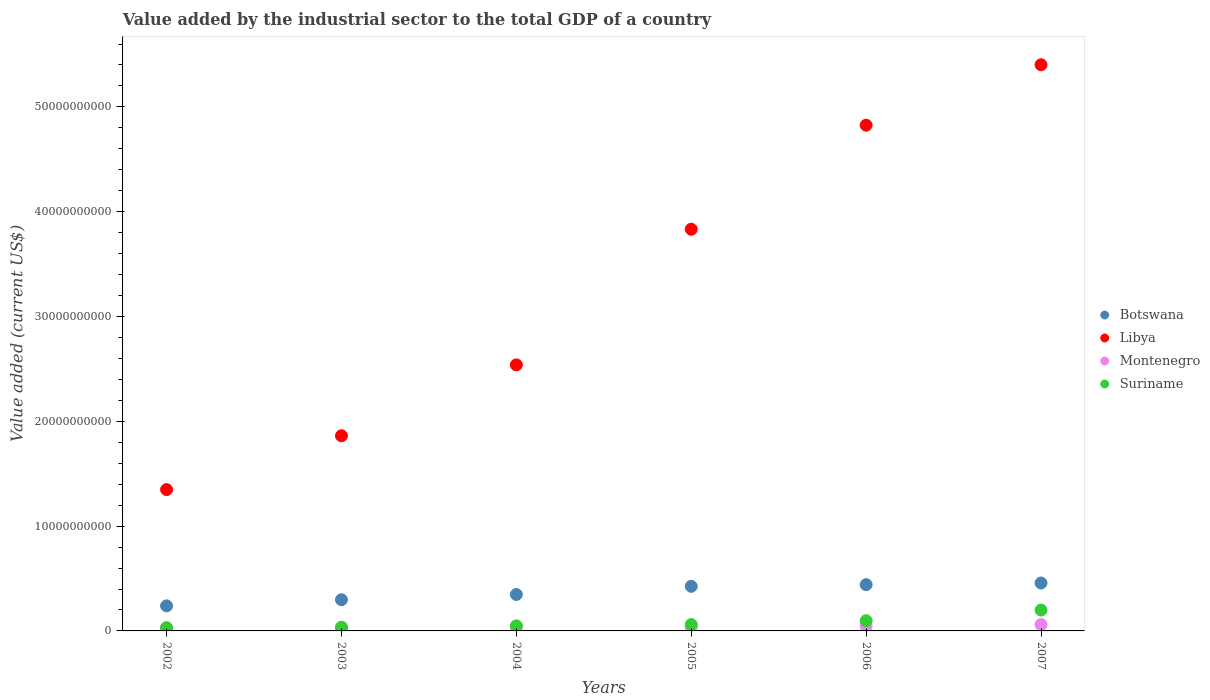Is the number of dotlines equal to the number of legend labels?
Give a very brief answer. Yes. What is the value added by the industrial sector to the total GDP in Montenegro in 2005?
Offer a terse response. 3.91e+08. Across all years, what is the maximum value added by the industrial sector to the total GDP in Montenegro?
Your answer should be very brief. 6.09e+08. Across all years, what is the minimum value added by the industrial sector to the total GDP in Botswana?
Offer a very short reply. 2.39e+09. In which year was the value added by the industrial sector to the total GDP in Libya minimum?
Provide a succinct answer. 2002. What is the total value added by the industrial sector to the total GDP in Libya in the graph?
Offer a terse response. 1.98e+11. What is the difference between the value added by the industrial sector to the total GDP in Libya in 2003 and that in 2005?
Give a very brief answer. -1.97e+1. What is the difference between the value added by the industrial sector to the total GDP in Libya in 2006 and the value added by the industrial sector to the total GDP in Montenegro in 2007?
Provide a short and direct response. 4.76e+1. What is the average value added by the industrial sector to the total GDP in Suriname per year?
Ensure brevity in your answer.  7.86e+08. In the year 2007, what is the difference between the value added by the industrial sector to the total GDP in Montenegro and value added by the industrial sector to the total GDP in Botswana?
Your response must be concise. -3.96e+09. In how many years, is the value added by the industrial sector to the total GDP in Botswana greater than 20000000000 US$?
Give a very brief answer. 0. What is the ratio of the value added by the industrial sector to the total GDP in Montenegro in 2002 to that in 2007?
Provide a short and direct response. 0.46. Is the value added by the industrial sector to the total GDP in Libya in 2005 less than that in 2006?
Your response must be concise. Yes. Is the difference between the value added by the industrial sector to the total GDP in Montenegro in 2003 and 2007 greater than the difference between the value added by the industrial sector to the total GDP in Botswana in 2003 and 2007?
Your answer should be compact. Yes. What is the difference between the highest and the second highest value added by the industrial sector to the total GDP in Montenegro?
Your answer should be compact. 1.60e+08. What is the difference between the highest and the lowest value added by the industrial sector to the total GDP in Libya?
Provide a succinct answer. 4.05e+1. Is it the case that in every year, the sum of the value added by the industrial sector to the total GDP in Botswana and value added by the industrial sector to the total GDP in Montenegro  is greater than the sum of value added by the industrial sector to the total GDP in Suriname and value added by the industrial sector to the total GDP in Libya?
Make the answer very short. No. Does the value added by the industrial sector to the total GDP in Montenegro monotonically increase over the years?
Your response must be concise. No. Is the value added by the industrial sector to the total GDP in Botswana strictly greater than the value added by the industrial sector to the total GDP in Montenegro over the years?
Your response must be concise. Yes. How many years are there in the graph?
Ensure brevity in your answer.  6. What is the difference between two consecutive major ticks on the Y-axis?
Make the answer very short. 1.00e+1. Does the graph contain any zero values?
Make the answer very short. No. Does the graph contain grids?
Offer a very short reply. No. Where does the legend appear in the graph?
Ensure brevity in your answer.  Center right. How many legend labels are there?
Ensure brevity in your answer.  4. What is the title of the graph?
Ensure brevity in your answer.  Value added by the industrial sector to the total GDP of a country. What is the label or title of the Y-axis?
Make the answer very short. Value added (current US$). What is the Value added (current US$) of Botswana in 2002?
Your answer should be very brief. 2.39e+09. What is the Value added (current US$) in Libya in 2002?
Give a very brief answer. 1.35e+1. What is the Value added (current US$) in Montenegro in 2002?
Your answer should be very brief. 2.77e+08. What is the Value added (current US$) in Suriname in 2002?
Your answer should be very brief. 3.08e+08. What is the Value added (current US$) in Botswana in 2003?
Make the answer very short. 2.98e+09. What is the Value added (current US$) of Libya in 2003?
Your answer should be compact. 1.86e+1. What is the Value added (current US$) of Montenegro in 2003?
Provide a succinct answer. 3.30e+08. What is the Value added (current US$) of Suriname in 2003?
Your answer should be compact. 3.55e+08. What is the Value added (current US$) of Botswana in 2004?
Provide a succinct answer. 3.48e+09. What is the Value added (current US$) of Libya in 2004?
Your answer should be compact. 2.54e+1. What is the Value added (current US$) in Montenegro in 2004?
Provide a short and direct response. 3.93e+08. What is the Value added (current US$) in Suriname in 2004?
Keep it short and to the point. 4.82e+08. What is the Value added (current US$) of Botswana in 2005?
Your answer should be very brief. 4.26e+09. What is the Value added (current US$) in Libya in 2005?
Give a very brief answer. 3.83e+1. What is the Value added (current US$) in Montenegro in 2005?
Make the answer very short. 3.91e+08. What is the Value added (current US$) of Suriname in 2005?
Keep it short and to the point. 6.07e+08. What is the Value added (current US$) in Botswana in 2006?
Offer a very short reply. 4.41e+09. What is the Value added (current US$) in Libya in 2006?
Provide a succinct answer. 4.83e+1. What is the Value added (current US$) of Montenegro in 2006?
Give a very brief answer. 4.49e+08. What is the Value added (current US$) in Suriname in 2006?
Your answer should be very brief. 9.76e+08. What is the Value added (current US$) in Botswana in 2007?
Keep it short and to the point. 4.57e+09. What is the Value added (current US$) of Libya in 2007?
Your answer should be compact. 5.40e+1. What is the Value added (current US$) in Montenegro in 2007?
Your answer should be very brief. 6.09e+08. What is the Value added (current US$) in Suriname in 2007?
Offer a very short reply. 1.99e+09. Across all years, what is the maximum Value added (current US$) in Botswana?
Your answer should be very brief. 4.57e+09. Across all years, what is the maximum Value added (current US$) of Libya?
Keep it short and to the point. 5.40e+1. Across all years, what is the maximum Value added (current US$) of Montenegro?
Keep it short and to the point. 6.09e+08. Across all years, what is the maximum Value added (current US$) in Suriname?
Ensure brevity in your answer.  1.99e+09. Across all years, what is the minimum Value added (current US$) of Botswana?
Provide a short and direct response. 2.39e+09. Across all years, what is the minimum Value added (current US$) in Libya?
Ensure brevity in your answer.  1.35e+1. Across all years, what is the minimum Value added (current US$) of Montenegro?
Your answer should be very brief. 2.77e+08. Across all years, what is the minimum Value added (current US$) of Suriname?
Your answer should be compact. 3.08e+08. What is the total Value added (current US$) in Botswana in the graph?
Ensure brevity in your answer.  2.21e+1. What is the total Value added (current US$) of Libya in the graph?
Make the answer very short. 1.98e+11. What is the total Value added (current US$) of Montenegro in the graph?
Offer a very short reply. 2.45e+09. What is the total Value added (current US$) in Suriname in the graph?
Keep it short and to the point. 4.72e+09. What is the difference between the Value added (current US$) of Botswana in 2002 and that in 2003?
Keep it short and to the point. -5.85e+08. What is the difference between the Value added (current US$) of Libya in 2002 and that in 2003?
Give a very brief answer. -5.14e+09. What is the difference between the Value added (current US$) in Montenegro in 2002 and that in 2003?
Offer a terse response. -5.26e+07. What is the difference between the Value added (current US$) in Suriname in 2002 and that in 2003?
Give a very brief answer. -4.67e+07. What is the difference between the Value added (current US$) of Botswana in 2002 and that in 2004?
Provide a short and direct response. -1.09e+09. What is the difference between the Value added (current US$) of Libya in 2002 and that in 2004?
Provide a short and direct response. -1.19e+1. What is the difference between the Value added (current US$) in Montenegro in 2002 and that in 2004?
Provide a short and direct response. -1.16e+08. What is the difference between the Value added (current US$) of Suriname in 2002 and that in 2004?
Your answer should be very brief. -1.74e+08. What is the difference between the Value added (current US$) in Botswana in 2002 and that in 2005?
Your answer should be compact. -1.86e+09. What is the difference between the Value added (current US$) of Libya in 2002 and that in 2005?
Your response must be concise. -2.48e+1. What is the difference between the Value added (current US$) of Montenegro in 2002 and that in 2005?
Make the answer very short. -1.14e+08. What is the difference between the Value added (current US$) of Suriname in 2002 and that in 2005?
Make the answer very short. -2.99e+08. What is the difference between the Value added (current US$) in Botswana in 2002 and that in 2006?
Provide a short and direct response. -2.02e+09. What is the difference between the Value added (current US$) of Libya in 2002 and that in 2006?
Ensure brevity in your answer.  -3.48e+1. What is the difference between the Value added (current US$) of Montenegro in 2002 and that in 2006?
Keep it short and to the point. -1.71e+08. What is the difference between the Value added (current US$) in Suriname in 2002 and that in 2006?
Your answer should be compact. -6.68e+08. What is the difference between the Value added (current US$) in Botswana in 2002 and that in 2007?
Your response must be concise. -2.18e+09. What is the difference between the Value added (current US$) in Libya in 2002 and that in 2007?
Provide a succinct answer. -4.05e+1. What is the difference between the Value added (current US$) of Montenegro in 2002 and that in 2007?
Provide a short and direct response. -3.31e+08. What is the difference between the Value added (current US$) of Suriname in 2002 and that in 2007?
Your response must be concise. -1.68e+09. What is the difference between the Value added (current US$) in Botswana in 2003 and that in 2004?
Give a very brief answer. -5.02e+08. What is the difference between the Value added (current US$) in Libya in 2003 and that in 2004?
Your answer should be very brief. -6.77e+09. What is the difference between the Value added (current US$) of Montenegro in 2003 and that in 2004?
Your answer should be very brief. -6.33e+07. What is the difference between the Value added (current US$) in Suriname in 2003 and that in 2004?
Keep it short and to the point. -1.27e+08. What is the difference between the Value added (current US$) of Botswana in 2003 and that in 2005?
Give a very brief answer. -1.28e+09. What is the difference between the Value added (current US$) of Libya in 2003 and that in 2005?
Your answer should be compact. -1.97e+1. What is the difference between the Value added (current US$) in Montenegro in 2003 and that in 2005?
Your answer should be very brief. -6.13e+07. What is the difference between the Value added (current US$) in Suriname in 2003 and that in 2005?
Offer a very short reply. -2.52e+08. What is the difference between the Value added (current US$) of Botswana in 2003 and that in 2006?
Offer a terse response. -1.44e+09. What is the difference between the Value added (current US$) in Libya in 2003 and that in 2006?
Offer a terse response. -2.96e+1. What is the difference between the Value added (current US$) in Montenegro in 2003 and that in 2006?
Your answer should be compact. -1.19e+08. What is the difference between the Value added (current US$) in Suriname in 2003 and that in 2006?
Your response must be concise. -6.21e+08. What is the difference between the Value added (current US$) in Botswana in 2003 and that in 2007?
Your answer should be very brief. -1.60e+09. What is the difference between the Value added (current US$) in Libya in 2003 and that in 2007?
Keep it short and to the point. -3.54e+1. What is the difference between the Value added (current US$) of Montenegro in 2003 and that in 2007?
Your answer should be very brief. -2.79e+08. What is the difference between the Value added (current US$) of Suriname in 2003 and that in 2007?
Ensure brevity in your answer.  -1.64e+09. What is the difference between the Value added (current US$) in Botswana in 2004 and that in 2005?
Make the answer very short. -7.79e+08. What is the difference between the Value added (current US$) of Libya in 2004 and that in 2005?
Provide a succinct answer. -1.29e+1. What is the difference between the Value added (current US$) in Montenegro in 2004 and that in 2005?
Give a very brief answer. 1.93e+06. What is the difference between the Value added (current US$) of Suriname in 2004 and that in 2005?
Provide a succinct answer. -1.25e+08. What is the difference between the Value added (current US$) of Botswana in 2004 and that in 2006?
Make the answer very short. -9.37e+08. What is the difference between the Value added (current US$) in Libya in 2004 and that in 2006?
Your answer should be compact. -2.29e+1. What is the difference between the Value added (current US$) of Montenegro in 2004 and that in 2006?
Offer a terse response. -5.56e+07. What is the difference between the Value added (current US$) of Suriname in 2004 and that in 2006?
Your response must be concise. -4.94e+08. What is the difference between the Value added (current US$) in Botswana in 2004 and that in 2007?
Your response must be concise. -1.10e+09. What is the difference between the Value added (current US$) in Libya in 2004 and that in 2007?
Ensure brevity in your answer.  -2.86e+1. What is the difference between the Value added (current US$) in Montenegro in 2004 and that in 2007?
Provide a succinct answer. -2.16e+08. What is the difference between the Value added (current US$) of Suriname in 2004 and that in 2007?
Provide a short and direct response. -1.51e+09. What is the difference between the Value added (current US$) of Botswana in 2005 and that in 2006?
Provide a short and direct response. -1.58e+08. What is the difference between the Value added (current US$) in Libya in 2005 and that in 2006?
Give a very brief answer. -9.93e+09. What is the difference between the Value added (current US$) in Montenegro in 2005 and that in 2006?
Offer a very short reply. -5.75e+07. What is the difference between the Value added (current US$) of Suriname in 2005 and that in 2006?
Your answer should be compact. -3.69e+08. What is the difference between the Value added (current US$) in Botswana in 2005 and that in 2007?
Your response must be concise. -3.17e+08. What is the difference between the Value added (current US$) in Libya in 2005 and that in 2007?
Provide a short and direct response. -1.57e+1. What is the difference between the Value added (current US$) in Montenegro in 2005 and that in 2007?
Offer a terse response. -2.17e+08. What is the difference between the Value added (current US$) in Suriname in 2005 and that in 2007?
Your response must be concise. -1.38e+09. What is the difference between the Value added (current US$) in Botswana in 2006 and that in 2007?
Ensure brevity in your answer.  -1.58e+08. What is the difference between the Value added (current US$) in Libya in 2006 and that in 2007?
Your answer should be compact. -5.77e+09. What is the difference between the Value added (current US$) of Montenegro in 2006 and that in 2007?
Offer a terse response. -1.60e+08. What is the difference between the Value added (current US$) in Suriname in 2006 and that in 2007?
Provide a short and direct response. -1.01e+09. What is the difference between the Value added (current US$) of Botswana in 2002 and the Value added (current US$) of Libya in 2003?
Make the answer very short. -1.62e+1. What is the difference between the Value added (current US$) of Botswana in 2002 and the Value added (current US$) of Montenegro in 2003?
Keep it short and to the point. 2.06e+09. What is the difference between the Value added (current US$) in Botswana in 2002 and the Value added (current US$) in Suriname in 2003?
Ensure brevity in your answer.  2.04e+09. What is the difference between the Value added (current US$) of Libya in 2002 and the Value added (current US$) of Montenegro in 2003?
Give a very brief answer. 1.32e+1. What is the difference between the Value added (current US$) in Libya in 2002 and the Value added (current US$) in Suriname in 2003?
Provide a succinct answer. 1.31e+1. What is the difference between the Value added (current US$) of Montenegro in 2002 and the Value added (current US$) of Suriname in 2003?
Keep it short and to the point. -7.72e+07. What is the difference between the Value added (current US$) in Botswana in 2002 and the Value added (current US$) in Libya in 2004?
Offer a very short reply. -2.30e+1. What is the difference between the Value added (current US$) in Botswana in 2002 and the Value added (current US$) in Montenegro in 2004?
Ensure brevity in your answer.  2.00e+09. What is the difference between the Value added (current US$) of Botswana in 2002 and the Value added (current US$) of Suriname in 2004?
Give a very brief answer. 1.91e+09. What is the difference between the Value added (current US$) in Libya in 2002 and the Value added (current US$) in Montenegro in 2004?
Offer a terse response. 1.31e+1. What is the difference between the Value added (current US$) of Libya in 2002 and the Value added (current US$) of Suriname in 2004?
Your answer should be compact. 1.30e+1. What is the difference between the Value added (current US$) of Montenegro in 2002 and the Value added (current US$) of Suriname in 2004?
Your response must be concise. -2.04e+08. What is the difference between the Value added (current US$) in Botswana in 2002 and the Value added (current US$) in Libya in 2005?
Offer a terse response. -3.59e+1. What is the difference between the Value added (current US$) in Botswana in 2002 and the Value added (current US$) in Montenegro in 2005?
Your response must be concise. 2.00e+09. What is the difference between the Value added (current US$) of Botswana in 2002 and the Value added (current US$) of Suriname in 2005?
Keep it short and to the point. 1.78e+09. What is the difference between the Value added (current US$) in Libya in 2002 and the Value added (current US$) in Montenegro in 2005?
Offer a terse response. 1.31e+1. What is the difference between the Value added (current US$) in Libya in 2002 and the Value added (current US$) in Suriname in 2005?
Your response must be concise. 1.29e+1. What is the difference between the Value added (current US$) of Montenegro in 2002 and the Value added (current US$) of Suriname in 2005?
Offer a terse response. -3.30e+08. What is the difference between the Value added (current US$) of Botswana in 2002 and the Value added (current US$) of Libya in 2006?
Provide a short and direct response. -4.59e+1. What is the difference between the Value added (current US$) in Botswana in 2002 and the Value added (current US$) in Montenegro in 2006?
Your answer should be very brief. 1.94e+09. What is the difference between the Value added (current US$) of Botswana in 2002 and the Value added (current US$) of Suriname in 2006?
Provide a short and direct response. 1.42e+09. What is the difference between the Value added (current US$) of Libya in 2002 and the Value added (current US$) of Montenegro in 2006?
Your response must be concise. 1.30e+1. What is the difference between the Value added (current US$) of Libya in 2002 and the Value added (current US$) of Suriname in 2006?
Make the answer very short. 1.25e+1. What is the difference between the Value added (current US$) in Montenegro in 2002 and the Value added (current US$) in Suriname in 2006?
Make the answer very short. -6.98e+08. What is the difference between the Value added (current US$) in Botswana in 2002 and the Value added (current US$) in Libya in 2007?
Your answer should be very brief. -5.16e+1. What is the difference between the Value added (current US$) in Botswana in 2002 and the Value added (current US$) in Montenegro in 2007?
Give a very brief answer. 1.78e+09. What is the difference between the Value added (current US$) of Botswana in 2002 and the Value added (current US$) of Suriname in 2007?
Make the answer very short. 4.01e+08. What is the difference between the Value added (current US$) of Libya in 2002 and the Value added (current US$) of Montenegro in 2007?
Provide a short and direct response. 1.29e+1. What is the difference between the Value added (current US$) of Libya in 2002 and the Value added (current US$) of Suriname in 2007?
Keep it short and to the point. 1.15e+1. What is the difference between the Value added (current US$) in Montenegro in 2002 and the Value added (current US$) in Suriname in 2007?
Make the answer very short. -1.71e+09. What is the difference between the Value added (current US$) in Botswana in 2003 and the Value added (current US$) in Libya in 2004?
Provide a succinct answer. -2.24e+1. What is the difference between the Value added (current US$) of Botswana in 2003 and the Value added (current US$) of Montenegro in 2004?
Ensure brevity in your answer.  2.58e+09. What is the difference between the Value added (current US$) of Botswana in 2003 and the Value added (current US$) of Suriname in 2004?
Your answer should be very brief. 2.49e+09. What is the difference between the Value added (current US$) of Libya in 2003 and the Value added (current US$) of Montenegro in 2004?
Give a very brief answer. 1.82e+1. What is the difference between the Value added (current US$) in Libya in 2003 and the Value added (current US$) in Suriname in 2004?
Your response must be concise. 1.81e+1. What is the difference between the Value added (current US$) of Montenegro in 2003 and the Value added (current US$) of Suriname in 2004?
Offer a terse response. -1.52e+08. What is the difference between the Value added (current US$) in Botswana in 2003 and the Value added (current US$) in Libya in 2005?
Make the answer very short. -3.54e+1. What is the difference between the Value added (current US$) of Botswana in 2003 and the Value added (current US$) of Montenegro in 2005?
Offer a very short reply. 2.58e+09. What is the difference between the Value added (current US$) in Botswana in 2003 and the Value added (current US$) in Suriname in 2005?
Your response must be concise. 2.37e+09. What is the difference between the Value added (current US$) in Libya in 2003 and the Value added (current US$) in Montenegro in 2005?
Offer a terse response. 1.82e+1. What is the difference between the Value added (current US$) of Libya in 2003 and the Value added (current US$) of Suriname in 2005?
Your answer should be compact. 1.80e+1. What is the difference between the Value added (current US$) of Montenegro in 2003 and the Value added (current US$) of Suriname in 2005?
Provide a short and direct response. -2.77e+08. What is the difference between the Value added (current US$) in Botswana in 2003 and the Value added (current US$) in Libya in 2006?
Provide a short and direct response. -4.53e+1. What is the difference between the Value added (current US$) of Botswana in 2003 and the Value added (current US$) of Montenegro in 2006?
Keep it short and to the point. 2.53e+09. What is the difference between the Value added (current US$) of Botswana in 2003 and the Value added (current US$) of Suriname in 2006?
Provide a succinct answer. 2.00e+09. What is the difference between the Value added (current US$) in Libya in 2003 and the Value added (current US$) in Montenegro in 2006?
Your answer should be very brief. 1.82e+1. What is the difference between the Value added (current US$) in Libya in 2003 and the Value added (current US$) in Suriname in 2006?
Make the answer very short. 1.76e+1. What is the difference between the Value added (current US$) of Montenegro in 2003 and the Value added (current US$) of Suriname in 2006?
Your response must be concise. -6.46e+08. What is the difference between the Value added (current US$) of Botswana in 2003 and the Value added (current US$) of Libya in 2007?
Offer a terse response. -5.10e+1. What is the difference between the Value added (current US$) of Botswana in 2003 and the Value added (current US$) of Montenegro in 2007?
Your response must be concise. 2.37e+09. What is the difference between the Value added (current US$) of Botswana in 2003 and the Value added (current US$) of Suriname in 2007?
Your answer should be compact. 9.85e+08. What is the difference between the Value added (current US$) in Libya in 2003 and the Value added (current US$) in Montenegro in 2007?
Your response must be concise. 1.80e+1. What is the difference between the Value added (current US$) of Libya in 2003 and the Value added (current US$) of Suriname in 2007?
Offer a terse response. 1.66e+1. What is the difference between the Value added (current US$) of Montenegro in 2003 and the Value added (current US$) of Suriname in 2007?
Keep it short and to the point. -1.66e+09. What is the difference between the Value added (current US$) in Botswana in 2004 and the Value added (current US$) in Libya in 2005?
Provide a succinct answer. -3.49e+1. What is the difference between the Value added (current US$) of Botswana in 2004 and the Value added (current US$) of Montenegro in 2005?
Offer a very short reply. 3.09e+09. What is the difference between the Value added (current US$) in Botswana in 2004 and the Value added (current US$) in Suriname in 2005?
Provide a short and direct response. 2.87e+09. What is the difference between the Value added (current US$) of Libya in 2004 and the Value added (current US$) of Montenegro in 2005?
Ensure brevity in your answer.  2.50e+1. What is the difference between the Value added (current US$) in Libya in 2004 and the Value added (current US$) in Suriname in 2005?
Provide a succinct answer. 2.48e+1. What is the difference between the Value added (current US$) in Montenegro in 2004 and the Value added (current US$) in Suriname in 2005?
Your response must be concise. -2.14e+08. What is the difference between the Value added (current US$) in Botswana in 2004 and the Value added (current US$) in Libya in 2006?
Keep it short and to the point. -4.48e+1. What is the difference between the Value added (current US$) in Botswana in 2004 and the Value added (current US$) in Montenegro in 2006?
Your answer should be very brief. 3.03e+09. What is the difference between the Value added (current US$) of Botswana in 2004 and the Value added (current US$) of Suriname in 2006?
Make the answer very short. 2.50e+09. What is the difference between the Value added (current US$) in Libya in 2004 and the Value added (current US$) in Montenegro in 2006?
Your response must be concise. 2.49e+1. What is the difference between the Value added (current US$) in Libya in 2004 and the Value added (current US$) in Suriname in 2006?
Give a very brief answer. 2.44e+1. What is the difference between the Value added (current US$) in Montenegro in 2004 and the Value added (current US$) in Suriname in 2006?
Offer a terse response. -5.82e+08. What is the difference between the Value added (current US$) of Botswana in 2004 and the Value added (current US$) of Libya in 2007?
Make the answer very short. -5.05e+1. What is the difference between the Value added (current US$) in Botswana in 2004 and the Value added (current US$) in Montenegro in 2007?
Provide a short and direct response. 2.87e+09. What is the difference between the Value added (current US$) of Botswana in 2004 and the Value added (current US$) of Suriname in 2007?
Give a very brief answer. 1.49e+09. What is the difference between the Value added (current US$) in Libya in 2004 and the Value added (current US$) in Montenegro in 2007?
Provide a short and direct response. 2.48e+1. What is the difference between the Value added (current US$) in Libya in 2004 and the Value added (current US$) in Suriname in 2007?
Provide a short and direct response. 2.34e+1. What is the difference between the Value added (current US$) in Montenegro in 2004 and the Value added (current US$) in Suriname in 2007?
Provide a succinct answer. -1.60e+09. What is the difference between the Value added (current US$) of Botswana in 2005 and the Value added (current US$) of Libya in 2006?
Offer a terse response. -4.40e+1. What is the difference between the Value added (current US$) in Botswana in 2005 and the Value added (current US$) in Montenegro in 2006?
Provide a succinct answer. 3.81e+09. What is the difference between the Value added (current US$) of Botswana in 2005 and the Value added (current US$) of Suriname in 2006?
Offer a terse response. 3.28e+09. What is the difference between the Value added (current US$) of Libya in 2005 and the Value added (current US$) of Montenegro in 2006?
Your answer should be very brief. 3.79e+1. What is the difference between the Value added (current US$) of Libya in 2005 and the Value added (current US$) of Suriname in 2006?
Offer a terse response. 3.74e+1. What is the difference between the Value added (current US$) of Montenegro in 2005 and the Value added (current US$) of Suriname in 2006?
Your response must be concise. -5.84e+08. What is the difference between the Value added (current US$) in Botswana in 2005 and the Value added (current US$) in Libya in 2007?
Offer a terse response. -4.98e+1. What is the difference between the Value added (current US$) of Botswana in 2005 and the Value added (current US$) of Montenegro in 2007?
Give a very brief answer. 3.65e+09. What is the difference between the Value added (current US$) in Botswana in 2005 and the Value added (current US$) in Suriname in 2007?
Your answer should be compact. 2.27e+09. What is the difference between the Value added (current US$) in Libya in 2005 and the Value added (current US$) in Montenegro in 2007?
Your answer should be compact. 3.77e+1. What is the difference between the Value added (current US$) of Libya in 2005 and the Value added (current US$) of Suriname in 2007?
Provide a short and direct response. 3.63e+1. What is the difference between the Value added (current US$) in Montenegro in 2005 and the Value added (current US$) in Suriname in 2007?
Give a very brief answer. -1.60e+09. What is the difference between the Value added (current US$) in Botswana in 2006 and the Value added (current US$) in Libya in 2007?
Offer a terse response. -4.96e+1. What is the difference between the Value added (current US$) in Botswana in 2006 and the Value added (current US$) in Montenegro in 2007?
Make the answer very short. 3.81e+09. What is the difference between the Value added (current US$) of Botswana in 2006 and the Value added (current US$) of Suriname in 2007?
Offer a terse response. 2.42e+09. What is the difference between the Value added (current US$) in Libya in 2006 and the Value added (current US$) in Montenegro in 2007?
Offer a terse response. 4.76e+1. What is the difference between the Value added (current US$) in Libya in 2006 and the Value added (current US$) in Suriname in 2007?
Offer a terse response. 4.63e+1. What is the difference between the Value added (current US$) of Montenegro in 2006 and the Value added (current US$) of Suriname in 2007?
Provide a short and direct response. -1.54e+09. What is the average Value added (current US$) of Botswana per year?
Your answer should be very brief. 3.68e+09. What is the average Value added (current US$) in Libya per year?
Your answer should be very brief. 3.30e+1. What is the average Value added (current US$) of Montenegro per year?
Offer a terse response. 4.08e+08. What is the average Value added (current US$) of Suriname per year?
Offer a terse response. 7.86e+08. In the year 2002, what is the difference between the Value added (current US$) of Botswana and Value added (current US$) of Libya?
Your answer should be very brief. -1.11e+1. In the year 2002, what is the difference between the Value added (current US$) of Botswana and Value added (current US$) of Montenegro?
Offer a terse response. 2.11e+09. In the year 2002, what is the difference between the Value added (current US$) in Botswana and Value added (current US$) in Suriname?
Provide a succinct answer. 2.08e+09. In the year 2002, what is the difference between the Value added (current US$) of Libya and Value added (current US$) of Montenegro?
Provide a short and direct response. 1.32e+1. In the year 2002, what is the difference between the Value added (current US$) of Libya and Value added (current US$) of Suriname?
Your answer should be compact. 1.32e+1. In the year 2002, what is the difference between the Value added (current US$) of Montenegro and Value added (current US$) of Suriname?
Offer a very short reply. -3.06e+07. In the year 2003, what is the difference between the Value added (current US$) in Botswana and Value added (current US$) in Libya?
Your answer should be very brief. -1.56e+1. In the year 2003, what is the difference between the Value added (current US$) in Botswana and Value added (current US$) in Montenegro?
Keep it short and to the point. 2.65e+09. In the year 2003, what is the difference between the Value added (current US$) in Botswana and Value added (current US$) in Suriname?
Provide a short and direct response. 2.62e+09. In the year 2003, what is the difference between the Value added (current US$) of Libya and Value added (current US$) of Montenegro?
Your response must be concise. 1.83e+1. In the year 2003, what is the difference between the Value added (current US$) of Libya and Value added (current US$) of Suriname?
Your response must be concise. 1.83e+1. In the year 2003, what is the difference between the Value added (current US$) of Montenegro and Value added (current US$) of Suriname?
Offer a very short reply. -2.46e+07. In the year 2004, what is the difference between the Value added (current US$) of Botswana and Value added (current US$) of Libya?
Make the answer very short. -2.19e+1. In the year 2004, what is the difference between the Value added (current US$) in Botswana and Value added (current US$) in Montenegro?
Provide a short and direct response. 3.08e+09. In the year 2004, what is the difference between the Value added (current US$) in Botswana and Value added (current US$) in Suriname?
Ensure brevity in your answer.  3.00e+09. In the year 2004, what is the difference between the Value added (current US$) in Libya and Value added (current US$) in Montenegro?
Offer a very short reply. 2.50e+1. In the year 2004, what is the difference between the Value added (current US$) of Libya and Value added (current US$) of Suriname?
Keep it short and to the point. 2.49e+1. In the year 2004, what is the difference between the Value added (current US$) in Montenegro and Value added (current US$) in Suriname?
Ensure brevity in your answer.  -8.85e+07. In the year 2005, what is the difference between the Value added (current US$) in Botswana and Value added (current US$) in Libya?
Your answer should be very brief. -3.41e+1. In the year 2005, what is the difference between the Value added (current US$) in Botswana and Value added (current US$) in Montenegro?
Keep it short and to the point. 3.86e+09. In the year 2005, what is the difference between the Value added (current US$) in Botswana and Value added (current US$) in Suriname?
Provide a short and direct response. 3.65e+09. In the year 2005, what is the difference between the Value added (current US$) in Libya and Value added (current US$) in Montenegro?
Provide a short and direct response. 3.79e+1. In the year 2005, what is the difference between the Value added (current US$) of Libya and Value added (current US$) of Suriname?
Your answer should be compact. 3.77e+1. In the year 2005, what is the difference between the Value added (current US$) in Montenegro and Value added (current US$) in Suriname?
Your response must be concise. -2.16e+08. In the year 2006, what is the difference between the Value added (current US$) of Botswana and Value added (current US$) of Libya?
Your response must be concise. -4.38e+1. In the year 2006, what is the difference between the Value added (current US$) in Botswana and Value added (current US$) in Montenegro?
Keep it short and to the point. 3.97e+09. In the year 2006, what is the difference between the Value added (current US$) in Botswana and Value added (current US$) in Suriname?
Provide a succinct answer. 3.44e+09. In the year 2006, what is the difference between the Value added (current US$) in Libya and Value added (current US$) in Montenegro?
Ensure brevity in your answer.  4.78e+1. In the year 2006, what is the difference between the Value added (current US$) of Libya and Value added (current US$) of Suriname?
Ensure brevity in your answer.  4.73e+1. In the year 2006, what is the difference between the Value added (current US$) in Montenegro and Value added (current US$) in Suriname?
Give a very brief answer. -5.27e+08. In the year 2007, what is the difference between the Value added (current US$) in Botswana and Value added (current US$) in Libya?
Provide a succinct answer. -4.95e+1. In the year 2007, what is the difference between the Value added (current US$) in Botswana and Value added (current US$) in Montenegro?
Offer a very short reply. 3.96e+09. In the year 2007, what is the difference between the Value added (current US$) of Botswana and Value added (current US$) of Suriname?
Your response must be concise. 2.58e+09. In the year 2007, what is the difference between the Value added (current US$) of Libya and Value added (current US$) of Montenegro?
Provide a succinct answer. 5.34e+1. In the year 2007, what is the difference between the Value added (current US$) in Libya and Value added (current US$) in Suriname?
Your answer should be compact. 5.20e+1. In the year 2007, what is the difference between the Value added (current US$) of Montenegro and Value added (current US$) of Suriname?
Your response must be concise. -1.38e+09. What is the ratio of the Value added (current US$) in Botswana in 2002 to that in 2003?
Your answer should be very brief. 0.8. What is the ratio of the Value added (current US$) of Libya in 2002 to that in 2003?
Your answer should be compact. 0.72. What is the ratio of the Value added (current US$) of Montenegro in 2002 to that in 2003?
Offer a very short reply. 0.84. What is the ratio of the Value added (current US$) in Suriname in 2002 to that in 2003?
Keep it short and to the point. 0.87. What is the ratio of the Value added (current US$) of Botswana in 2002 to that in 2004?
Provide a short and direct response. 0.69. What is the ratio of the Value added (current US$) in Libya in 2002 to that in 2004?
Your response must be concise. 0.53. What is the ratio of the Value added (current US$) of Montenegro in 2002 to that in 2004?
Your response must be concise. 0.71. What is the ratio of the Value added (current US$) of Suriname in 2002 to that in 2004?
Your answer should be very brief. 0.64. What is the ratio of the Value added (current US$) in Botswana in 2002 to that in 2005?
Your answer should be very brief. 0.56. What is the ratio of the Value added (current US$) in Libya in 2002 to that in 2005?
Keep it short and to the point. 0.35. What is the ratio of the Value added (current US$) in Montenegro in 2002 to that in 2005?
Offer a very short reply. 0.71. What is the ratio of the Value added (current US$) in Suriname in 2002 to that in 2005?
Ensure brevity in your answer.  0.51. What is the ratio of the Value added (current US$) of Botswana in 2002 to that in 2006?
Offer a terse response. 0.54. What is the ratio of the Value added (current US$) of Libya in 2002 to that in 2006?
Provide a succinct answer. 0.28. What is the ratio of the Value added (current US$) in Montenegro in 2002 to that in 2006?
Keep it short and to the point. 0.62. What is the ratio of the Value added (current US$) in Suriname in 2002 to that in 2006?
Your answer should be compact. 0.32. What is the ratio of the Value added (current US$) in Botswana in 2002 to that in 2007?
Provide a short and direct response. 0.52. What is the ratio of the Value added (current US$) of Libya in 2002 to that in 2007?
Give a very brief answer. 0.25. What is the ratio of the Value added (current US$) in Montenegro in 2002 to that in 2007?
Offer a very short reply. 0.46. What is the ratio of the Value added (current US$) in Suriname in 2002 to that in 2007?
Keep it short and to the point. 0.15. What is the ratio of the Value added (current US$) of Botswana in 2003 to that in 2004?
Offer a very short reply. 0.86. What is the ratio of the Value added (current US$) in Libya in 2003 to that in 2004?
Provide a short and direct response. 0.73. What is the ratio of the Value added (current US$) of Montenegro in 2003 to that in 2004?
Offer a terse response. 0.84. What is the ratio of the Value added (current US$) in Suriname in 2003 to that in 2004?
Offer a terse response. 0.74. What is the ratio of the Value added (current US$) in Botswana in 2003 to that in 2005?
Give a very brief answer. 0.7. What is the ratio of the Value added (current US$) in Libya in 2003 to that in 2005?
Provide a succinct answer. 0.49. What is the ratio of the Value added (current US$) in Montenegro in 2003 to that in 2005?
Keep it short and to the point. 0.84. What is the ratio of the Value added (current US$) in Suriname in 2003 to that in 2005?
Offer a very short reply. 0.58. What is the ratio of the Value added (current US$) of Botswana in 2003 to that in 2006?
Make the answer very short. 0.67. What is the ratio of the Value added (current US$) of Libya in 2003 to that in 2006?
Keep it short and to the point. 0.39. What is the ratio of the Value added (current US$) in Montenegro in 2003 to that in 2006?
Provide a succinct answer. 0.74. What is the ratio of the Value added (current US$) of Suriname in 2003 to that in 2006?
Your answer should be compact. 0.36. What is the ratio of the Value added (current US$) of Botswana in 2003 to that in 2007?
Offer a terse response. 0.65. What is the ratio of the Value added (current US$) in Libya in 2003 to that in 2007?
Your answer should be compact. 0.34. What is the ratio of the Value added (current US$) of Montenegro in 2003 to that in 2007?
Give a very brief answer. 0.54. What is the ratio of the Value added (current US$) in Suriname in 2003 to that in 2007?
Keep it short and to the point. 0.18. What is the ratio of the Value added (current US$) of Botswana in 2004 to that in 2005?
Provide a short and direct response. 0.82. What is the ratio of the Value added (current US$) of Libya in 2004 to that in 2005?
Offer a very short reply. 0.66. What is the ratio of the Value added (current US$) in Suriname in 2004 to that in 2005?
Your answer should be very brief. 0.79. What is the ratio of the Value added (current US$) of Botswana in 2004 to that in 2006?
Ensure brevity in your answer.  0.79. What is the ratio of the Value added (current US$) of Libya in 2004 to that in 2006?
Your response must be concise. 0.53. What is the ratio of the Value added (current US$) in Montenegro in 2004 to that in 2006?
Offer a terse response. 0.88. What is the ratio of the Value added (current US$) of Suriname in 2004 to that in 2006?
Keep it short and to the point. 0.49. What is the ratio of the Value added (current US$) in Botswana in 2004 to that in 2007?
Offer a very short reply. 0.76. What is the ratio of the Value added (current US$) in Libya in 2004 to that in 2007?
Keep it short and to the point. 0.47. What is the ratio of the Value added (current US$) in Montenegro in 2004 to that in 2007?
Ensure brevity in your answer.  0.65. What is the ratio of the Value added (current US$) of Suriname in 2004 to that in 2007?
Keep it short and to the point. 0.24. What is the ratio of the Value added (current US$) of Botswana in 2005 to that in 2006?
Your answer should be compact. 0.96. What is the ratio of the Value added (current US$) in Libya in 2005 to that in 2006?
Provide a succinct answer. 0.79. What is the ratio of the Value added (current US$) of Montenegro in 2005 to that in 2006?
Offer a terse response. 0.87. What is the ratio of the Value added (current US$) in Suriname in 2005 to that in 2006?
Your answer should be compact. 0.62. What is the ratio of the Value added (current US$) in Botswana in 2005 to that in 2007?
Give a very brief answer. 0.93. What is the ratio of the Value added (current US$) in Libya in 2005 to that in 2007?
Offer a terse response. 0.71. What is the ratio of the Value added (current US$) in Montenegro in 2005 to that in 2007?
Ensure brevity in your answer.  0.64. What is the ratio of the Value added (current US$) in Suriname in 2005 to that in 2007?
Provide a short and direct response. 0.3. What is the ratio of the Value added (current US$) of Botswana in 2006 to that in 2007?
Make the answer very short. 0.97. What is the ratio of the Value added (current US$) in Libya in 2006 to that in 2007?
Ensure brevity in your answer.  0.89. What is the ratio of the Value added (current US$) in Montenegro in 2006 to that in 2007?
Your answer should be very brief. 0.74. What is the ratio of the Value added (current US$) in Suriname in 2006 to that in 2007?
Provide a succinct answer. 0.49. What is the difference between the highest and the second highest Value added (current US$) in Botswana?
Offer a terse response. 1.58e+08. What is the difference between the highest and the second highest Value added (current US$) in Libya?
Ensure brevity in your answer.  5.77e+09. What is the difference between the highest and the second highest Value added (current US$) in Montenegro?
Offer a terse response. 1.60e+08. What is the difference between the highest and the second highest Value added (current US$) in Suriname?
Your response must be concise. 1.01e+09. What is the difference between the highest and the lowest Value added (current US$) of Botswana?
Offer a very short reply. 2.18e+09. What is the difference between the highest and the lowest Value added (current US$) of Libya?
Provide a succinct answer. 4.05e+1. What is the difference between the highest and the lowest Value added (current US$) of Montenegro?
Ensure brevity in your answer.  3.31e+08. What is the difference between the highest and the lowest Value added (current US$) of Suriname?
Offer a very short reply. 1.68e+09. 